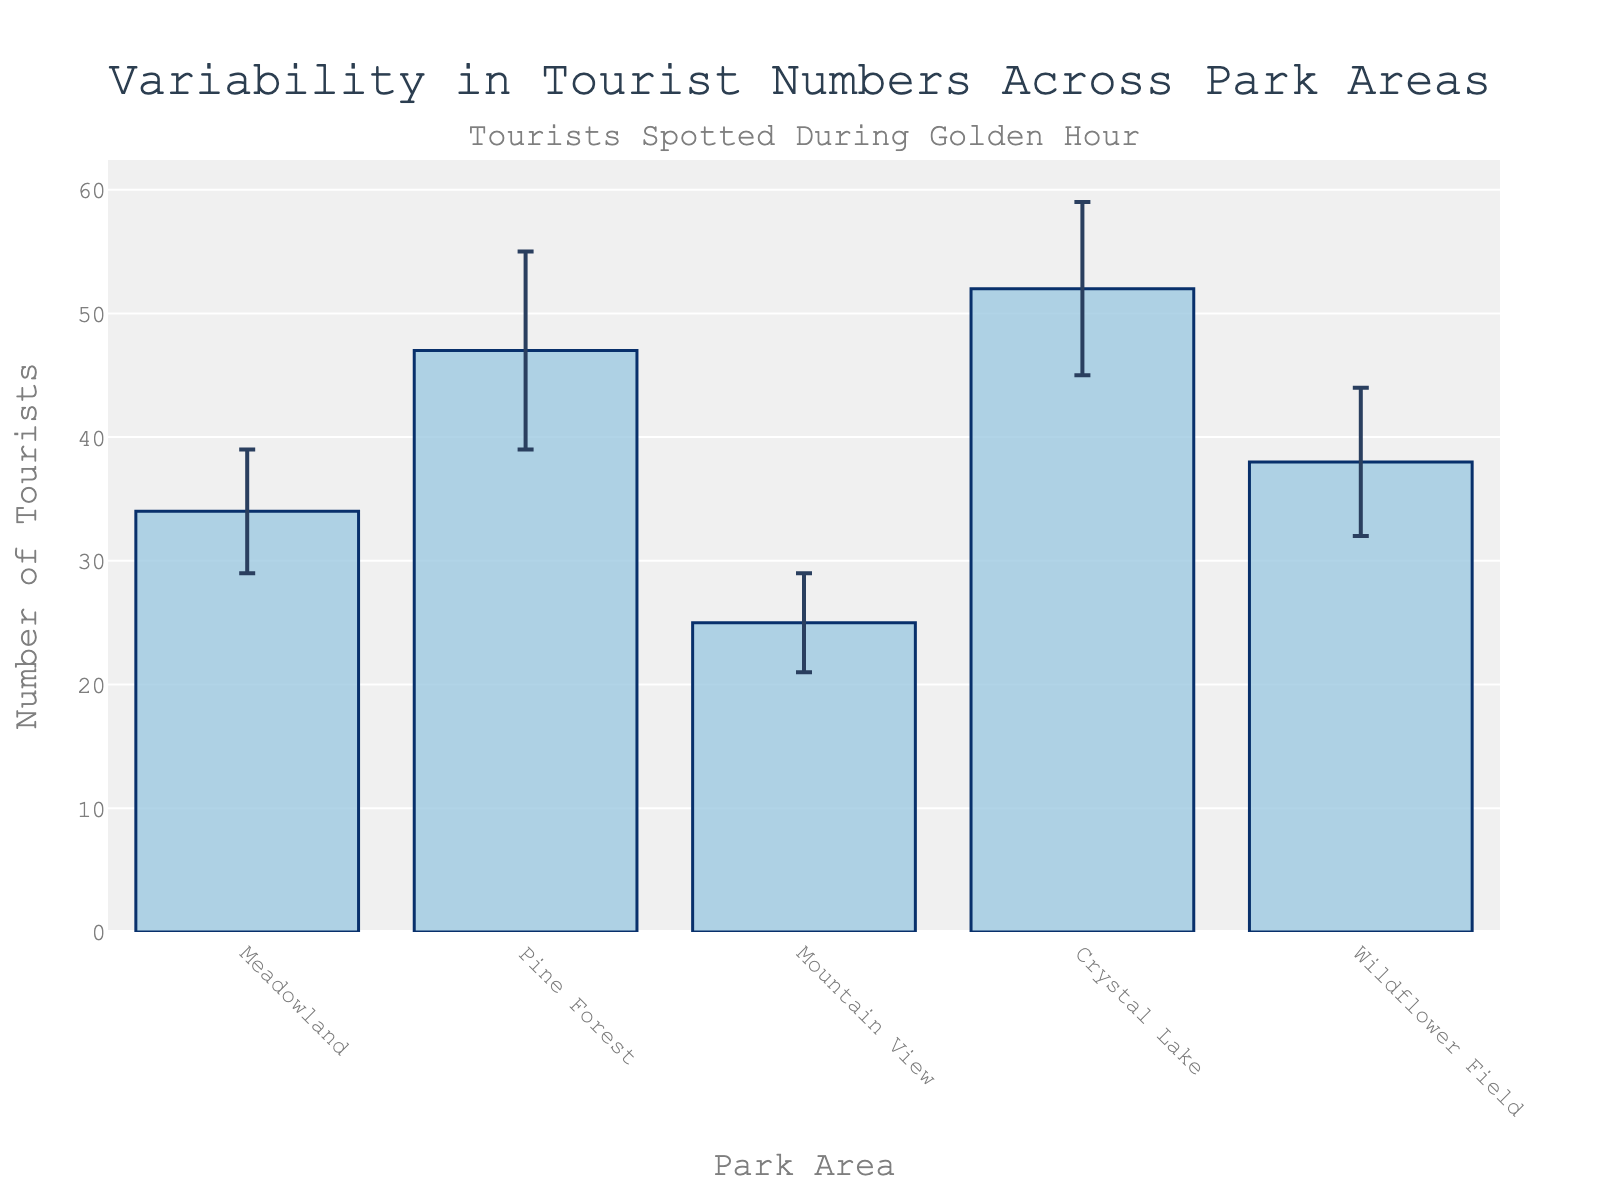What is the mean number of tourists at Crystal Lake? The figure shows the mean number of tourists at each park area. Look for 'Crystal Lake' on the x-axis and read the corresponding bar height.
Answer: 52 Which park area has the smallest number of tourists during golden hour? Compare the heights of all bars. The smallest height corresponds to 'Mountain View'.
Answer: Mountain View What is the range of mean tourist numbers across all park areas? Find the difference between the highest mean (52 at Crystal Lake) and the lowest mean (25 at Mountain View).
Answer: 27 Which park area has the highest variability in tourist numbers? Look for the bar with the largest error bar, which indicates the highest standard deviation. This corresponds to 'Pine Forest'.
Answer: Pine Forest What is the sum of the mean numbers of tourists at Meadowland and Wildflower Field? Add the mean values of Meadowland (34) and Wildflower Field (38).
Answer: 72 How does the number of tourists at Meadowland compare to that at Pine Forest? The mean number of tourists at Meadowland is 34, whereas at Pine Forest it is 47. Pine Forest has more tourists.
Answer: Pine Forest has more tourists What is the error range for the number of tourists at Crystal Lake? The error range is determined by the standard deviation. For Crystal Lake, it is 52 ± 7, so the range is 45 to 59.
Answer: 45 to 59 Which park areas have a mean number of tourists greater than 40? Compare the mean values for all park areas; those greater than 40 are Pine Forest (47) and Crystal Lake (52).
Answer: Pine Forest, Crystal Lake What is the average mean number of tourists across all park areas? Add up all the mean numbers (34 + 47 + 25 + 52 + 38) and divide by the number of areas (5).
Answer: 39.2 If you combine the total mean number of tourists in Mountain View and Crystal Lake, how does it compare to the total in Pine Forest? The combined mean for Mountain View (25) and Crystal Lake (52) is 77. The mean for Pine Forest alone is 47. 77 is greater than 47.
Answer: Greater than Pine Forest 